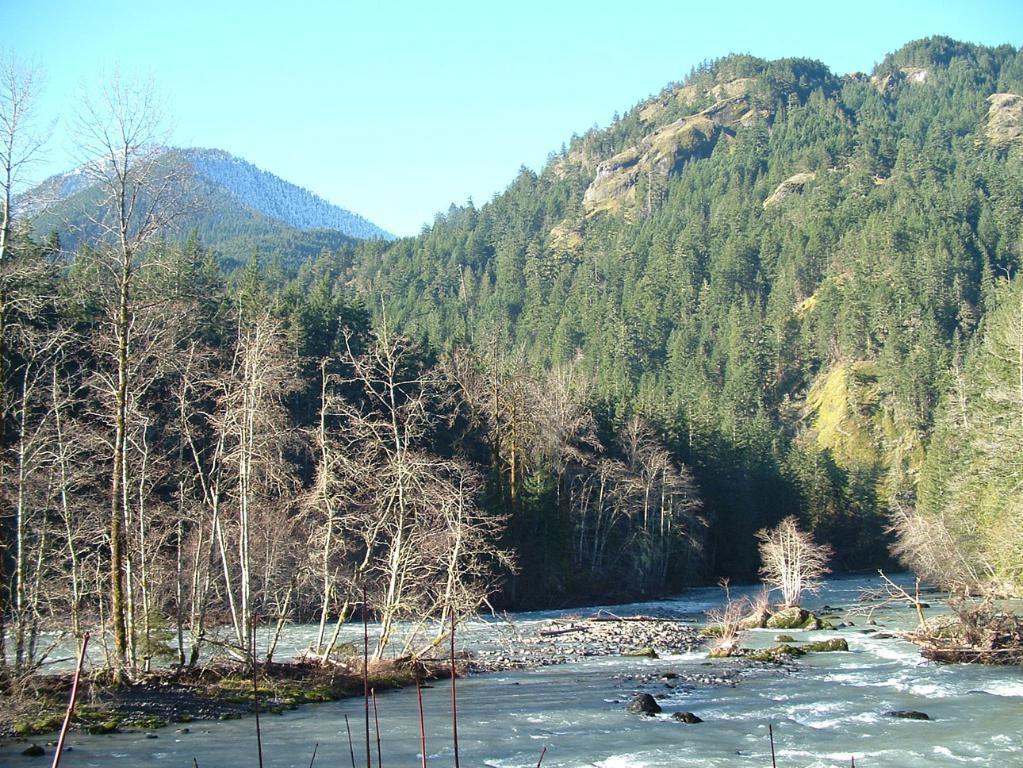How would you summarize this image in a sentence or two? In the image,there is a beautiful flowing river,in between the river there are small stones and rocks. Around the river there is a thicket and in the background there is a mountain. 